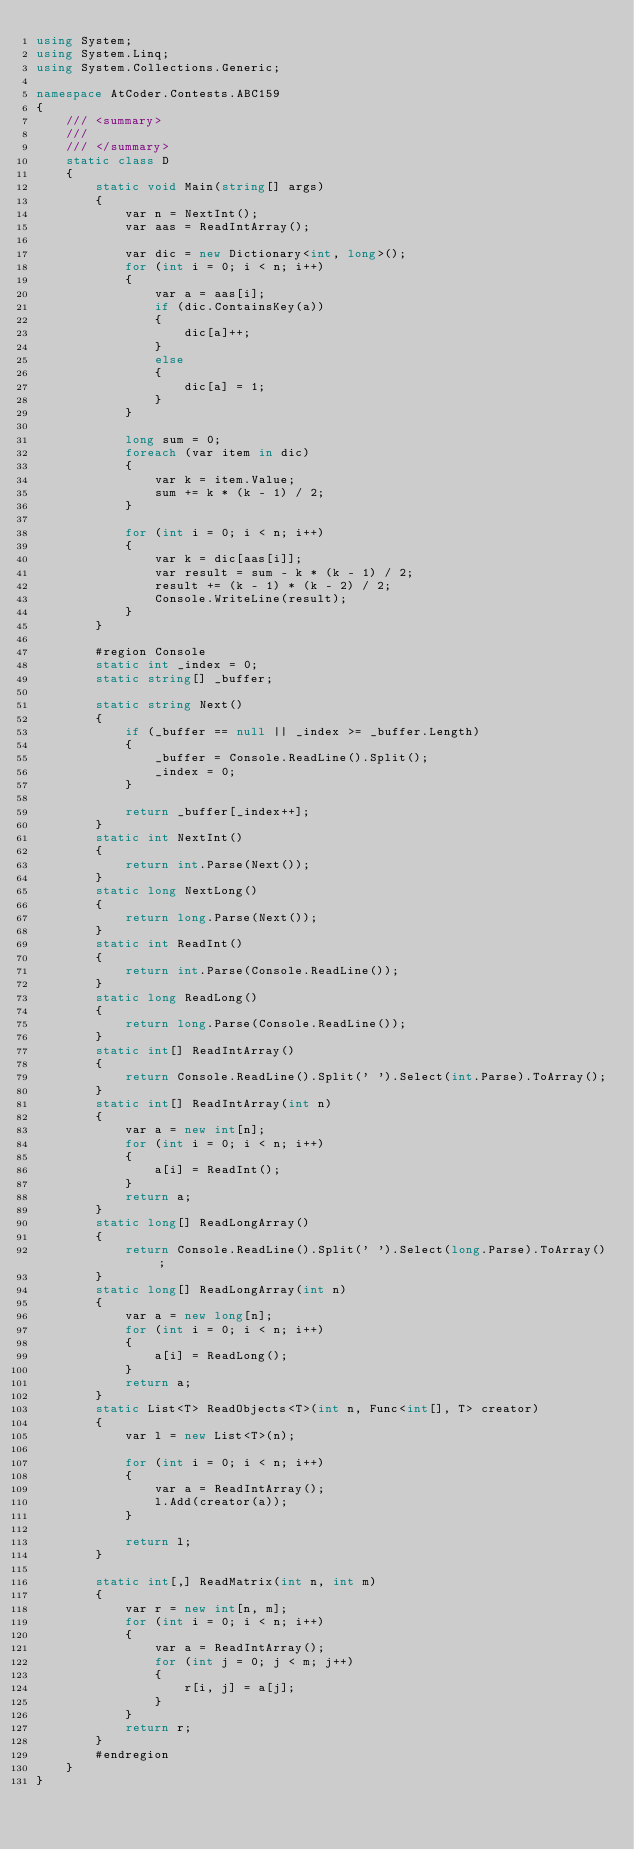Convert code to text. <code><loc_0><loc_0><loc_500><loc_500><_C#_>using System;
using System.Linq;
using System.Collections.Generic;

namespace AtCoder.Contests.ABC159
{
    /// <summary>
    /// 
    /// </summary>
    static class D
    {
        static void Main(string[] args)
        {
            var n = NextInt();
            var aas = ReadIntArray();

            var dic = new Dictionary<int, long>();
            for (int i = 0; i < n; i++)
            {
                var a = aas[i];
                if (dic.ContainsKey(a))
                {
                    dic[a]++;
                }
                else
                {
                    dic[a] = 1;
                }
            }

            long sum = 0;
            foreach (var item in dic)
            {
                var k = item.Value;
                sum += k * (k - 1) / 2;
            }

            for (int i = 0; i < n; i++)
            {
                var k = dic[aas[i]];
                var result = sum - k * (k - 1) / 2;
                result += (k - 1) * (k - 2) / 2;
                Console.WriteLine(result);
            }
        }

        #region Console
        static int _index = 0;
        static string[] _buffer;

        static string Next()
        {
            if (_buffer == null || _index >= _buffer.Length)
            {
                _buffer = Console.ReadLine().Split();
                _index = 0;
            }

            return _buffer[_index++];
        }
        static int NextInt()
        {
            return int.Parse(Next());
        }
        static long NextLong()
        {
            return long.Parse(Next());
        }
        static int ReadInt()
        {
            return int.Parse(Console.ReadLine());
        }
        static long ReadLong()
        {
            return long.Parse(Console.ReadLine());
        }
        static int[] ReadIntArray()
        {
            return Console.ReadLine().Split(' ').Select(int.Parse).ToArray();
        }
        static int[] ReadIntArray(int n)
        {
            var a = new int[n];
            for (int i = 0; i < n; i++)
            {
                a[i] = ReadInt();
            }
            return a;
        }
        static long[] ReadLongArray()
        {
            return Console.ReadLine().Split(' ').Select(long.Parse).ToArray();
        }
        static long[] ReadLongArray(int n)
        {
            var a = new long[n];
            for (int i = 0; i < n; i++)
            {
                a[i] = ReadLong();
            }
            return a;
        }
        static List<T> ReadObjects<T>(int n, Func<int[], T> creator)
        {
            var l = new List<T>(n);

            for (int i = 0; i < n; i++)
            {
                var a = ReadIntArray();
                l.Add(creator(a));
            }

            return l;
        }

        static int[,] ReadMatrix(int n, int m)
        {
            var r = new int[n, m];
            for (int i = 0; i < n; i++)
            {
                var a = ReadIntArray();
                for (int j = 0; j < m; j++)
                {
                    r[i, j] = a[j];
                }
            }
            return r;
        }
        #endregion
    }
}
</code> 